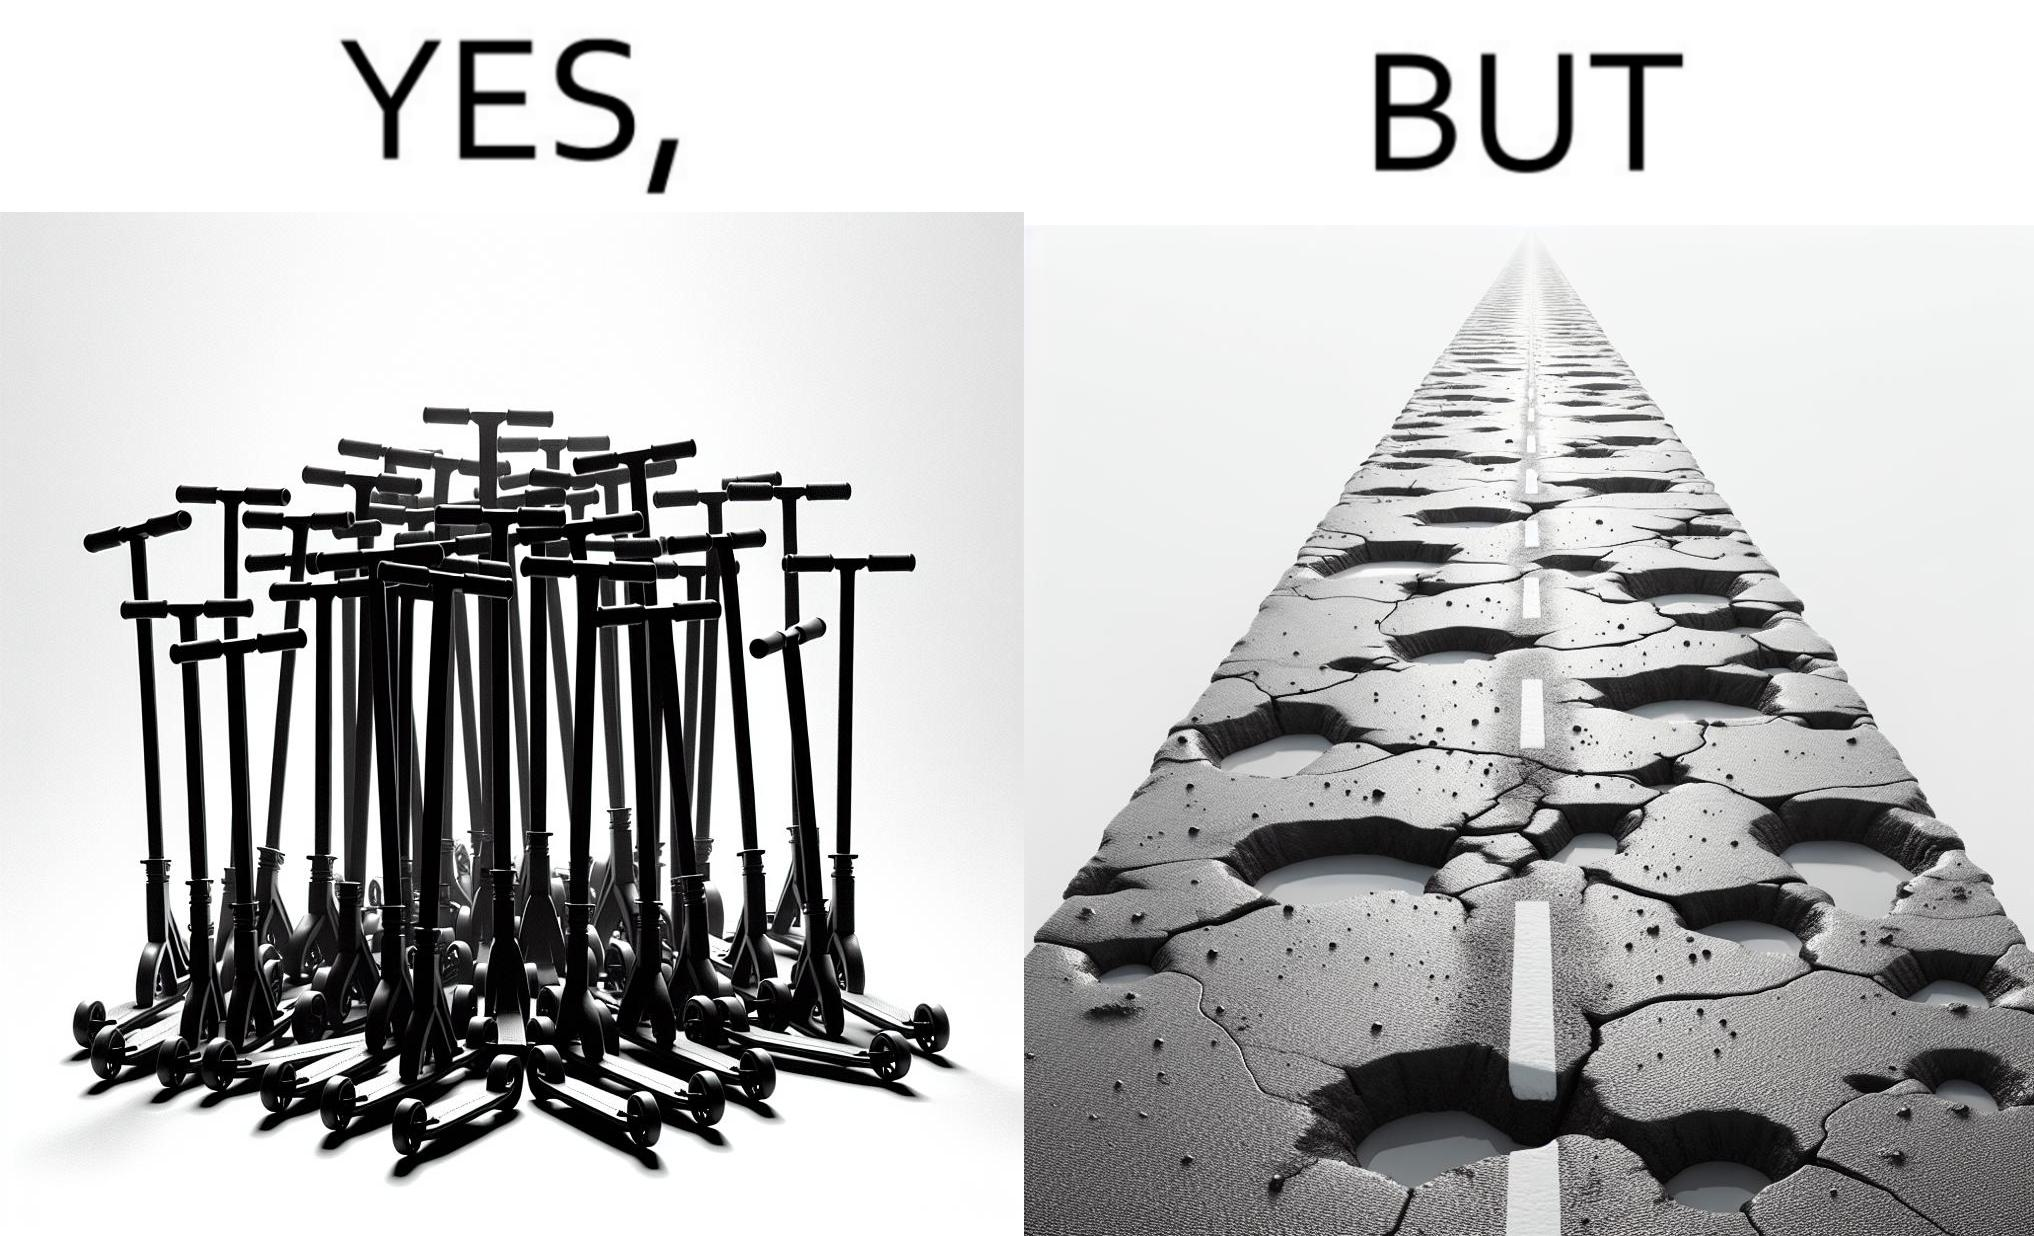Would you classify this image as satirical? Yes, this image is satirical. 